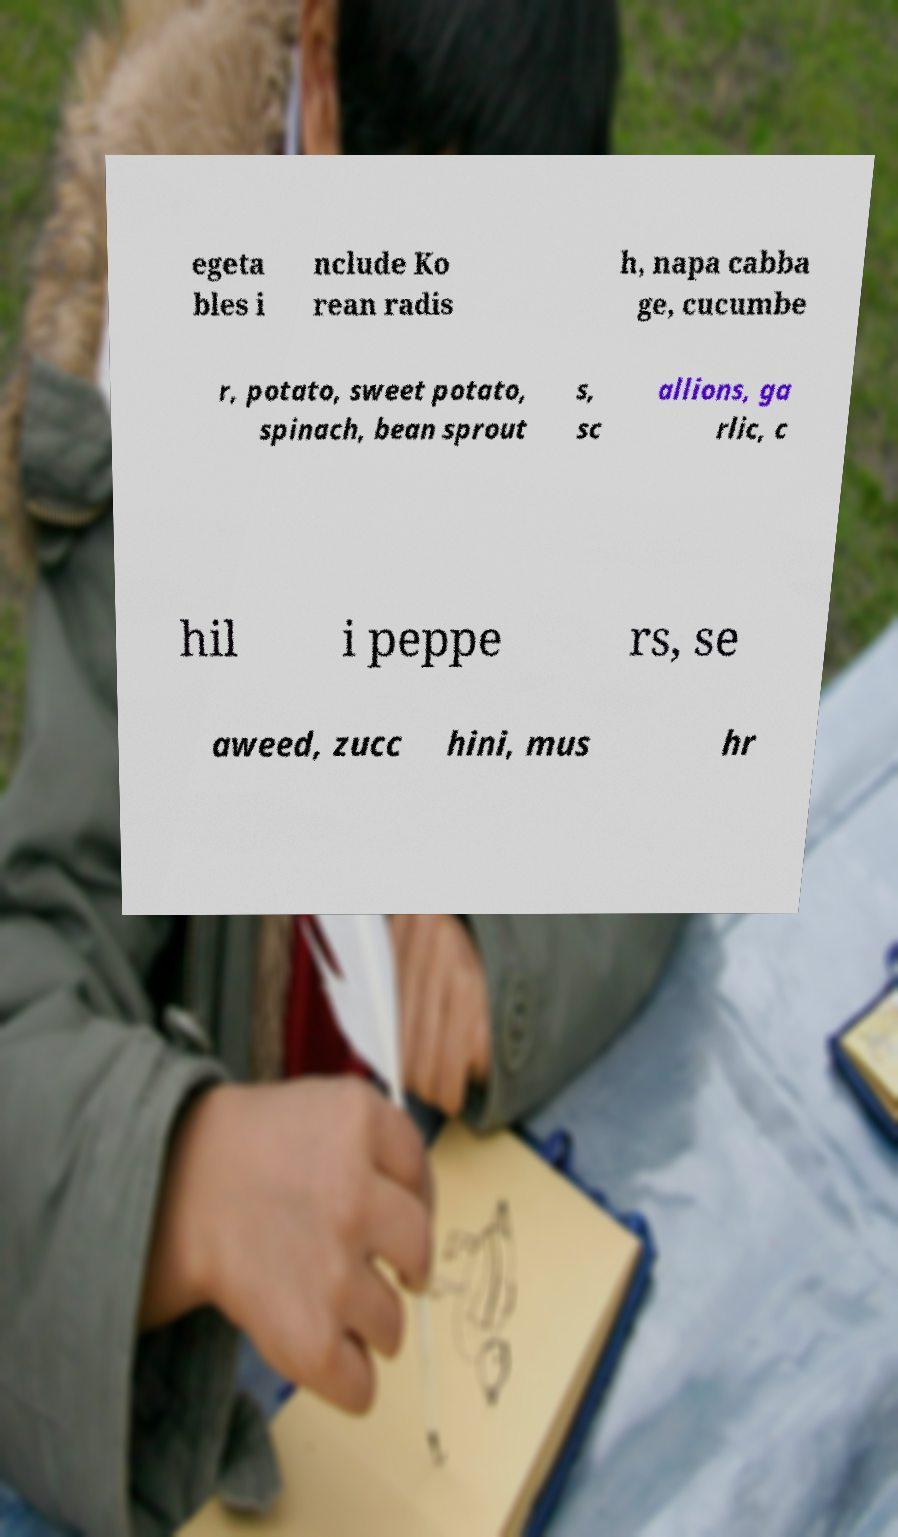Could you extract and type out the text from this image? egeta bles i nclude Ko rean radis h, napa cabba ge, cucumbe r, potato, sweet potato, spinach, bean sprout s, sc allions, ga rlic, c hil i peppe rs, se aweed, zucc hini, mus hr 